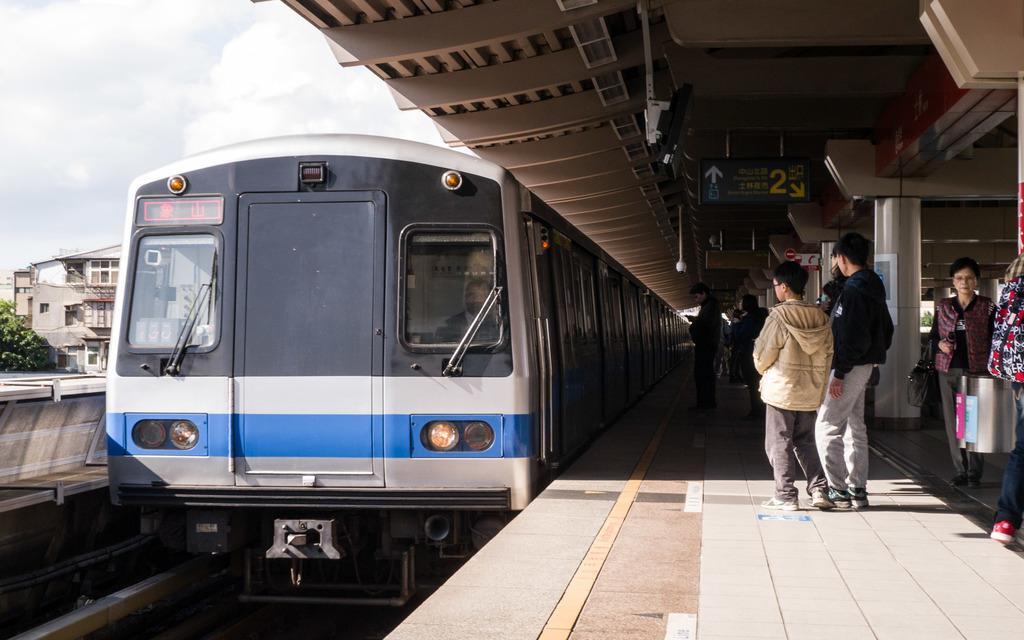Please provide a concise description of this image. This image is taken in a railway station. At the top of the image there is the sky with clouds. On the left side of the image there are a few buildings. There are a few trees. There is a platform. On the right side of the image there is a platform. There is a roof. There are a few iron bars and there are a few pillars. There are a few boards with a text on them. There are a few lights. Many people are standing on the platform and a few are walking. In the middle of the image there is a train on the railway track. 